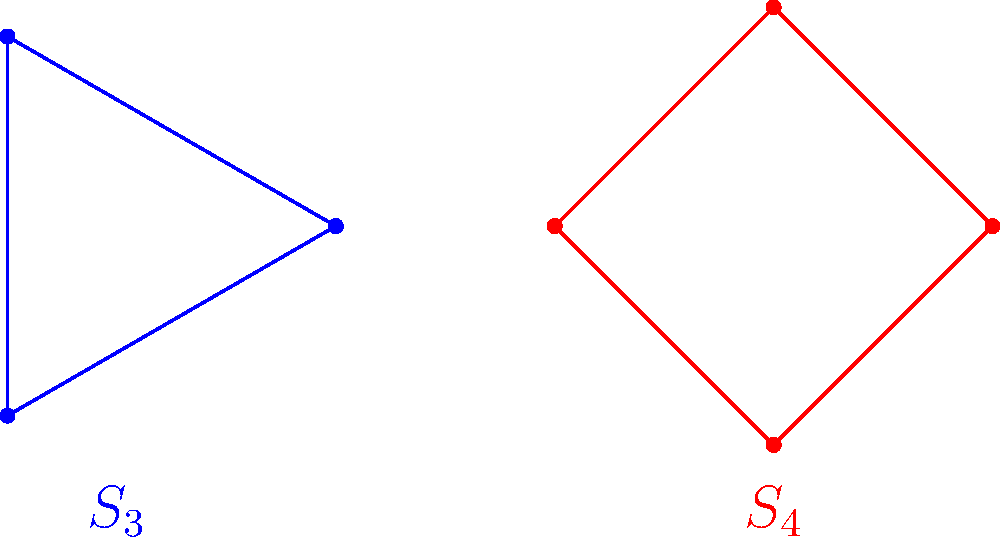Compare the cycle graphs of the symmetric groups $S_3$ and $S_4$ shown above. Which group has a higher proportion of elements that are cycles of maximum length? Let's approach this step-by-step:

1) First, recall that the maximum length cycle in $S_n$ is n.

2) For $S_3$:
   - Total elements: $3! = 6$
   - 3-cycles (max length): $(1,2,3)$ and $(1,3,2)$
   - Number of 3-cycles: 2
   - Proportion: $\frac{2}{6} = \frac{1}{3}$

3) For $S_4$:
   - Total elements: $4! = 24$
   - 4-cycles (max length): $(1,2,3,4)$, $(1,2,4,3)$, $(1,3,2,4)$, $(1,3,4,2)$, $(1,4,2,3)$, $(1,4,3,2)$
   - Number of 4-cycles: 6
   - Proportion: $\frac{6}{24} = \frac{1}{4}$

4) Comparing the proportions:
   $S_3: \frac{1}{3}$ vs $S_4: \frac{1}{4}$

5) $\frac{1}{3} > \frac{1}{4}$

Therefore, $S_3$ has a higher proportion of elements that are cycles of maximum length.
Answer: $S_3$ 